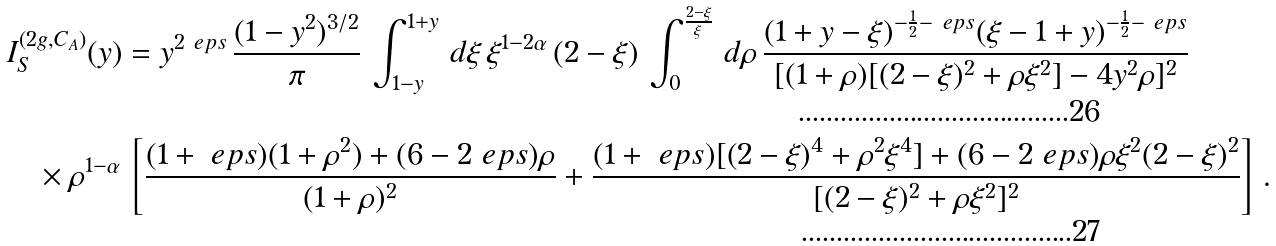<formula> <loc_0><loc_0><loc_500><loc_500>& I _ { S } ^ { ( 2 g , C _ { A } ) } ( y ) = y ^ { 2 \ e p s } \, \frac { ( 1 - y ^ { 2 } ) ^ { 3 / 2 } } { \pi } \, \int _ { 1 - y } ^ { 1 + y } \, d \xi \, \xi ^ { 1 - 2 \alpha } \, ( 2 - \xi ) \, \int _ { 0 } ^ { \frac { 2 - \xi } { \xi } } \, d \rho \, \frac { ( 1 + y - \xi ) ^ { - \frac { 1 } { 2 } - \ e p s } ( \xi - 1 + y ) ^ { - \frac { 1 } { 2 } - \ e p s } } { [ ( 1 + \rho ) [ ( 2 - \xi ) ^ { 2 } + \rho \xi ^ { 2 } ] - 4 y ^ { 2 } \rho ] ^ { 2 } } \\ & \quad \times \rho ^ { 1 - \alpha } \, \left [ \frac { ( 1 + \ e p s ) ( 1 + \rho ^ { 2 } ) + ( 6 - 2 \ e p s ) \rho } { ( 1 + \rho ) ^ { 2 } } + \frac { ( 1 + \ e p s ) [ ( 2 - \xi ) ^ { 4 } + \rho ^ { 2 } \xi ^ { 4 } ] + ( 6 - 2 \ e p s ) \rho \xi ^ { 2 } ( 2 - \xi ) ^ { 2 } } { [ ( 2 - \xi ) ^ { 2 } + \rho \xi ^ { 2 } ] ^ { 2 } } \right ] \, .</formula> 